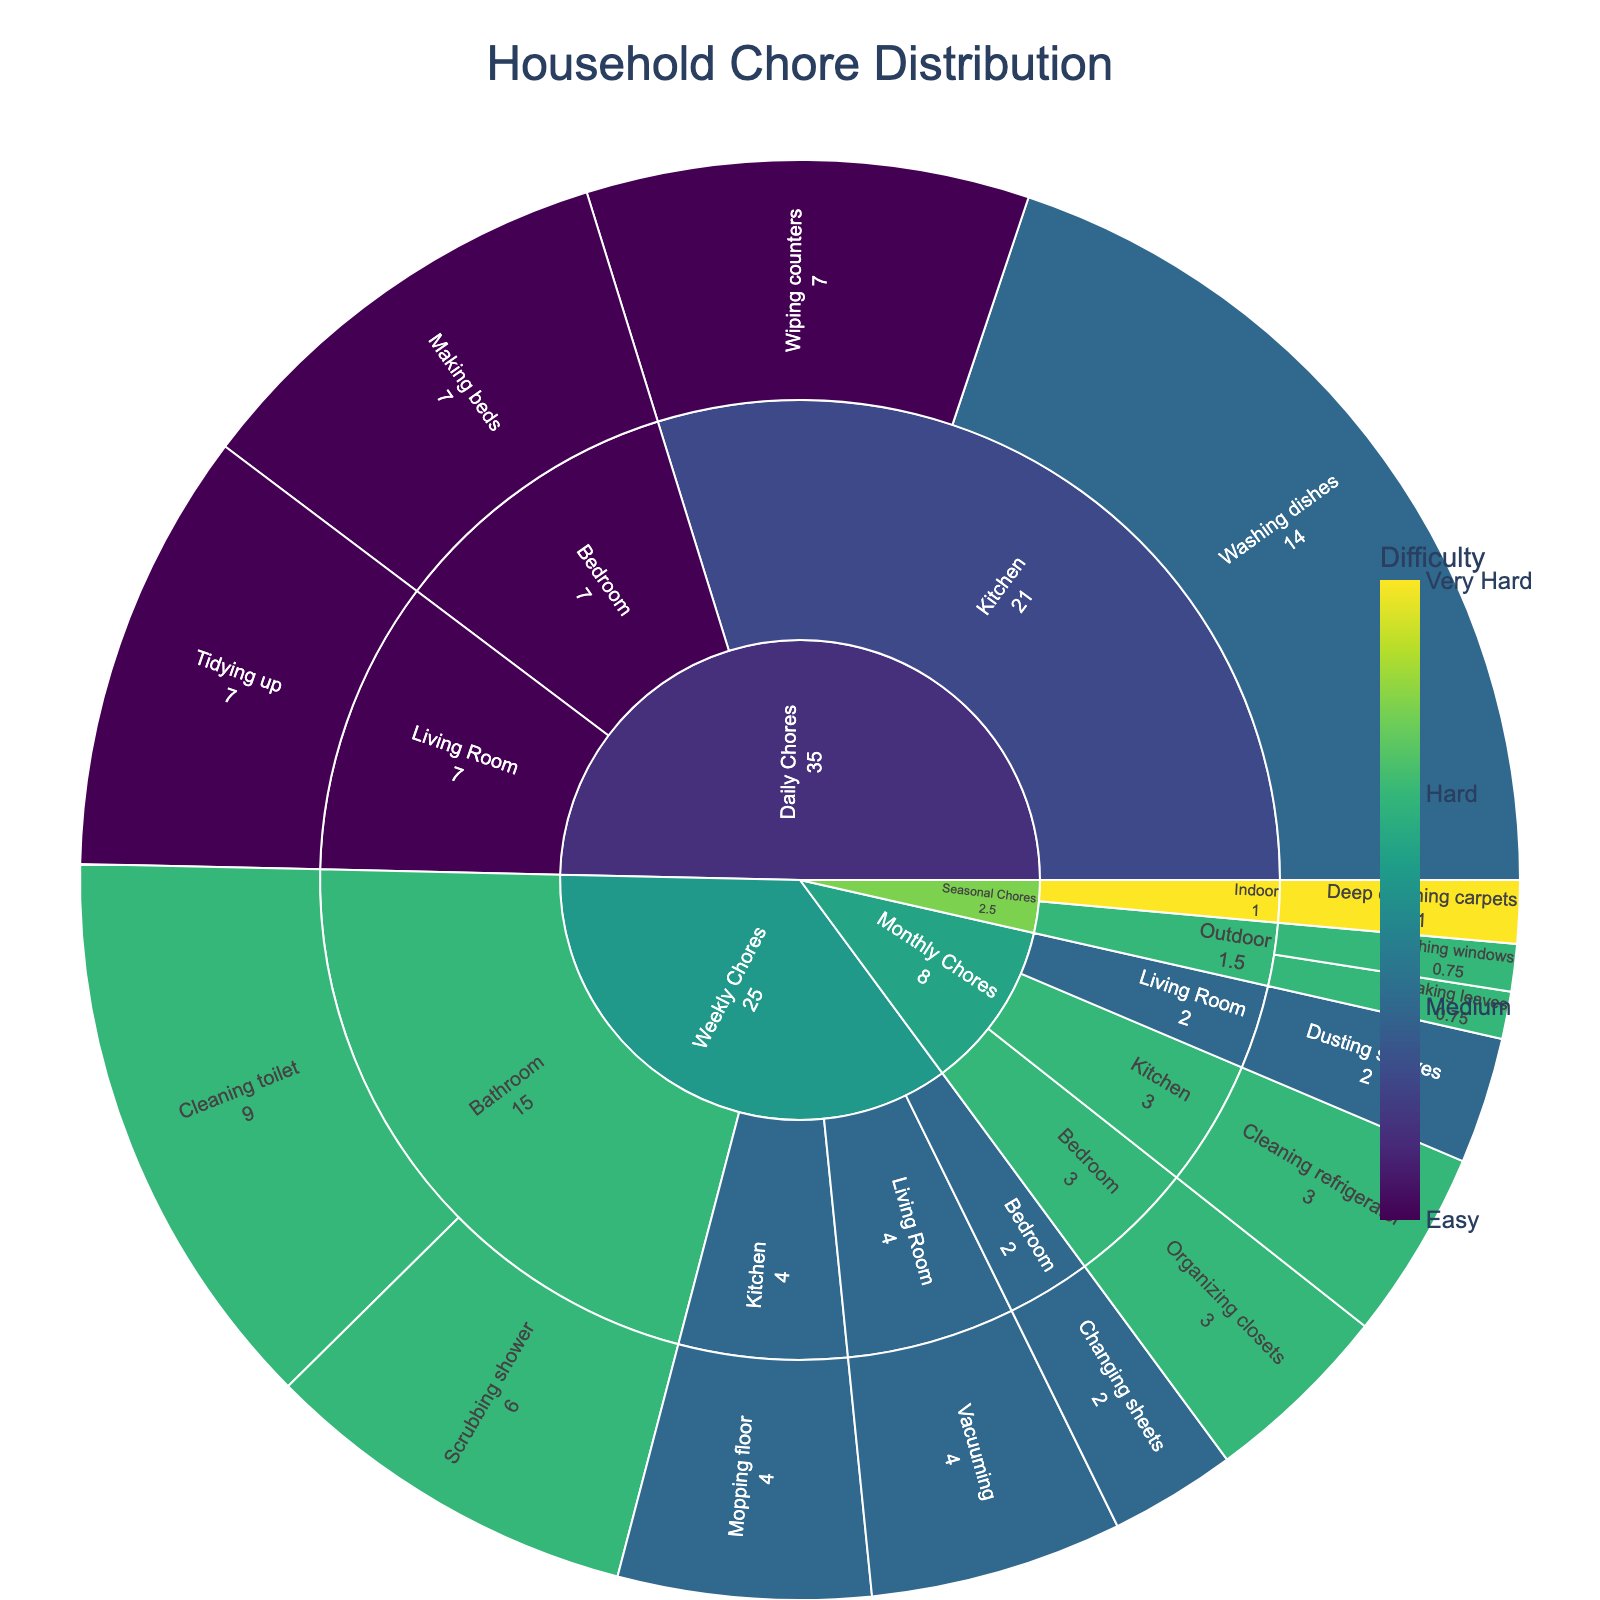What's the title of the chart? The title is located at the top center of the chart, in a larger font compared to other texts.
Answer: Household Chore Distribution Which household category has the highest total value in the chart? By observing the outer rings of the sunburst plot, you can see that the size of the slice reflects the sum of the values of its inner categories.
Answer: Daily Chores What is the frequency of tidying up in the Living Room? Hover over the section for "Tidying up" under "Living Room" to see the frequency displayed in the hover information.
Answer: 7 Which chore has the highest difficulty level? Look for the chore segment colored with the darkest shade of the color scale, indicating the hardest level.
Answer: Deep cleaning carpets How is the value calculated for each task? The value for each task is calculated by multiplying the frequency by the difficulty level, visible in the hover information.
Answer: Frequency x Difficulty Compare the total values of Kitchen and Bedroom subcategories under Weekly Chores. Which is higher? Calculate the total value by adding the individual task values within the Kitchen and Bedroom subcategories under Weekly Chores. Kitchen: Mopping floor (2x2=4). Bedroom: Changing sheets (1x2=2).
Answer: Kitchen What is the combined value of all Monthly Chores? Sum the values of all tasks listed under Monthly Chores. Cleaning refrigerator (1x3=3), Dusting shelves (1x2=2), Organizing closets (1x3=3). Total is 3+2+3.
Answer: 8 Which Seasonal Chore has the lowest frequency? Look at the frequency values for all Seasonal Chores and identify the lowest. Since all seasonal chores have the same frequency of 0.25, this one is trivial.
Answer: All the same (0.25) What is the most frequent chore in the Kitchen? Check the frequency values for all tasks under the Kitchen subcategories and identify the highest. Washing dishes and Wiping counters both have a frequency of 7.
Answer: Washing dishes / Wiping counters Which category contains the most difficult task, and what is the task? Identify the task with the highest difficulty level and trace it back to its category in the chart.
Answer: Seasonal Chores, Deep cleaning carpets 